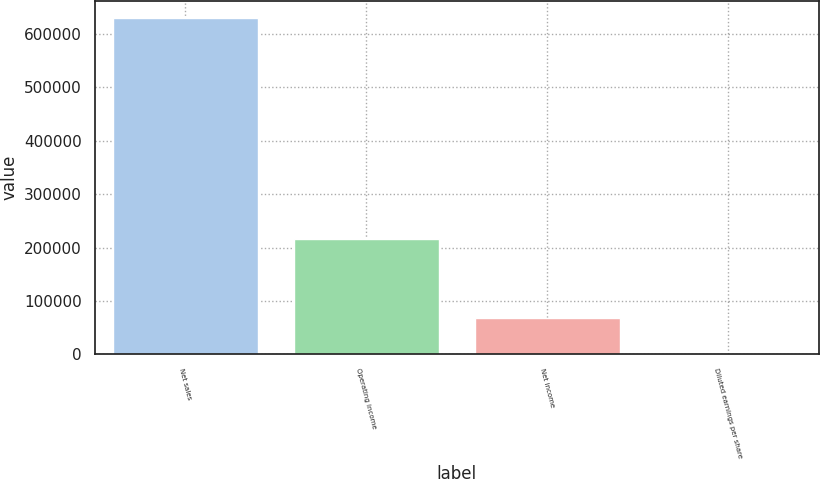<chart> <loc_0><loc_0><loc_500><loc_500><bar_chart><fcel>Net sales<fcel>Operating income<fcel>Net income<fcel>Diluted earnings per share<nl><fcel>630513<fcel>215260<fcel>68753<fcel>1.42<nl></chart> 